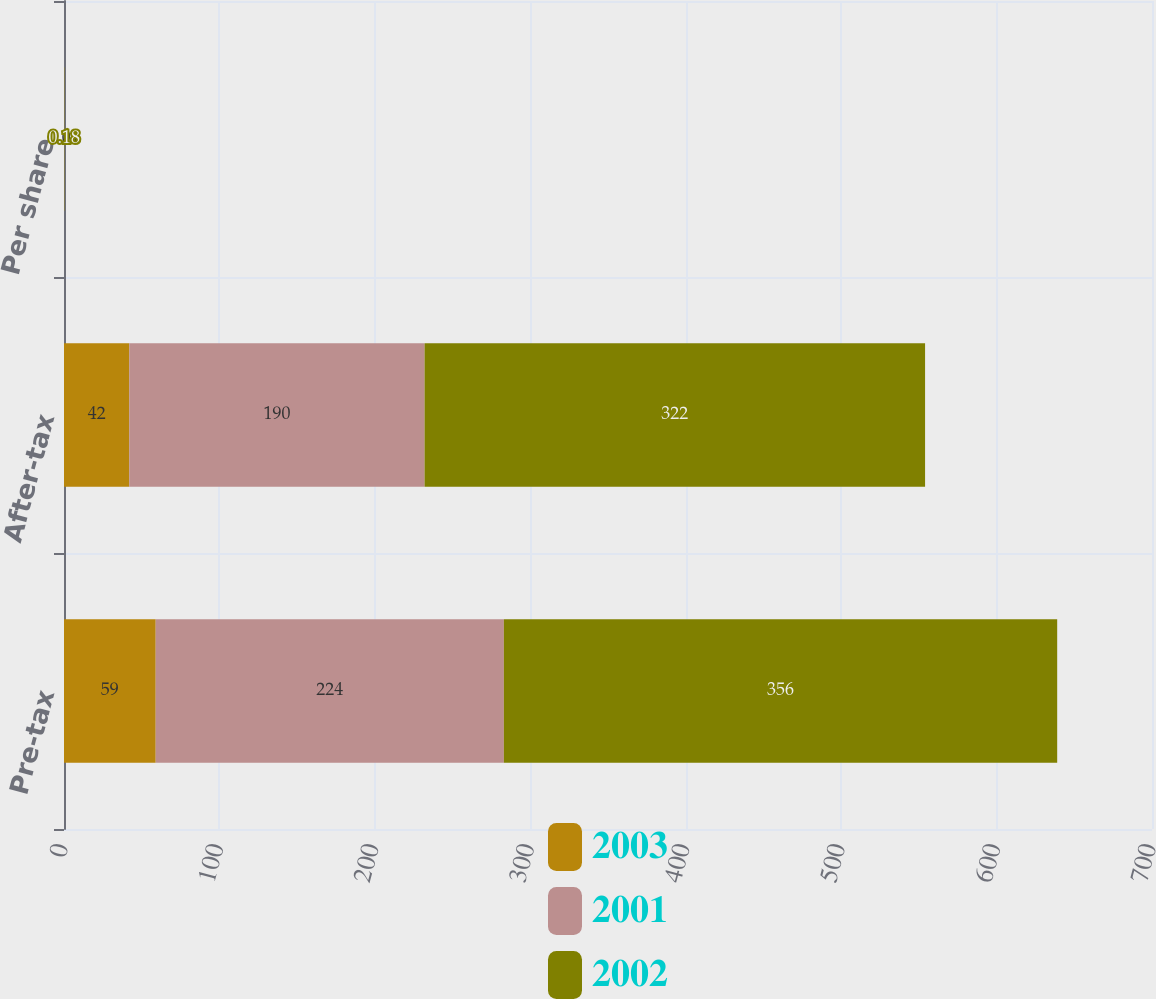<chart> <loc_0><loc_0><loc_500><loc_500><stacked_bar_chart><ecel><fcel>Pre-tax<fcel>After-tax<fcel>Per share<nl><fcel>2003<fcel>59<fcel>42<fcel>0.02<nl><fcel>2001<fcel>224<fcel>190<fcel>0.11<nl><fcel>2002<fcel>356<fcel>322<fcel>0.18<nl></chart> 